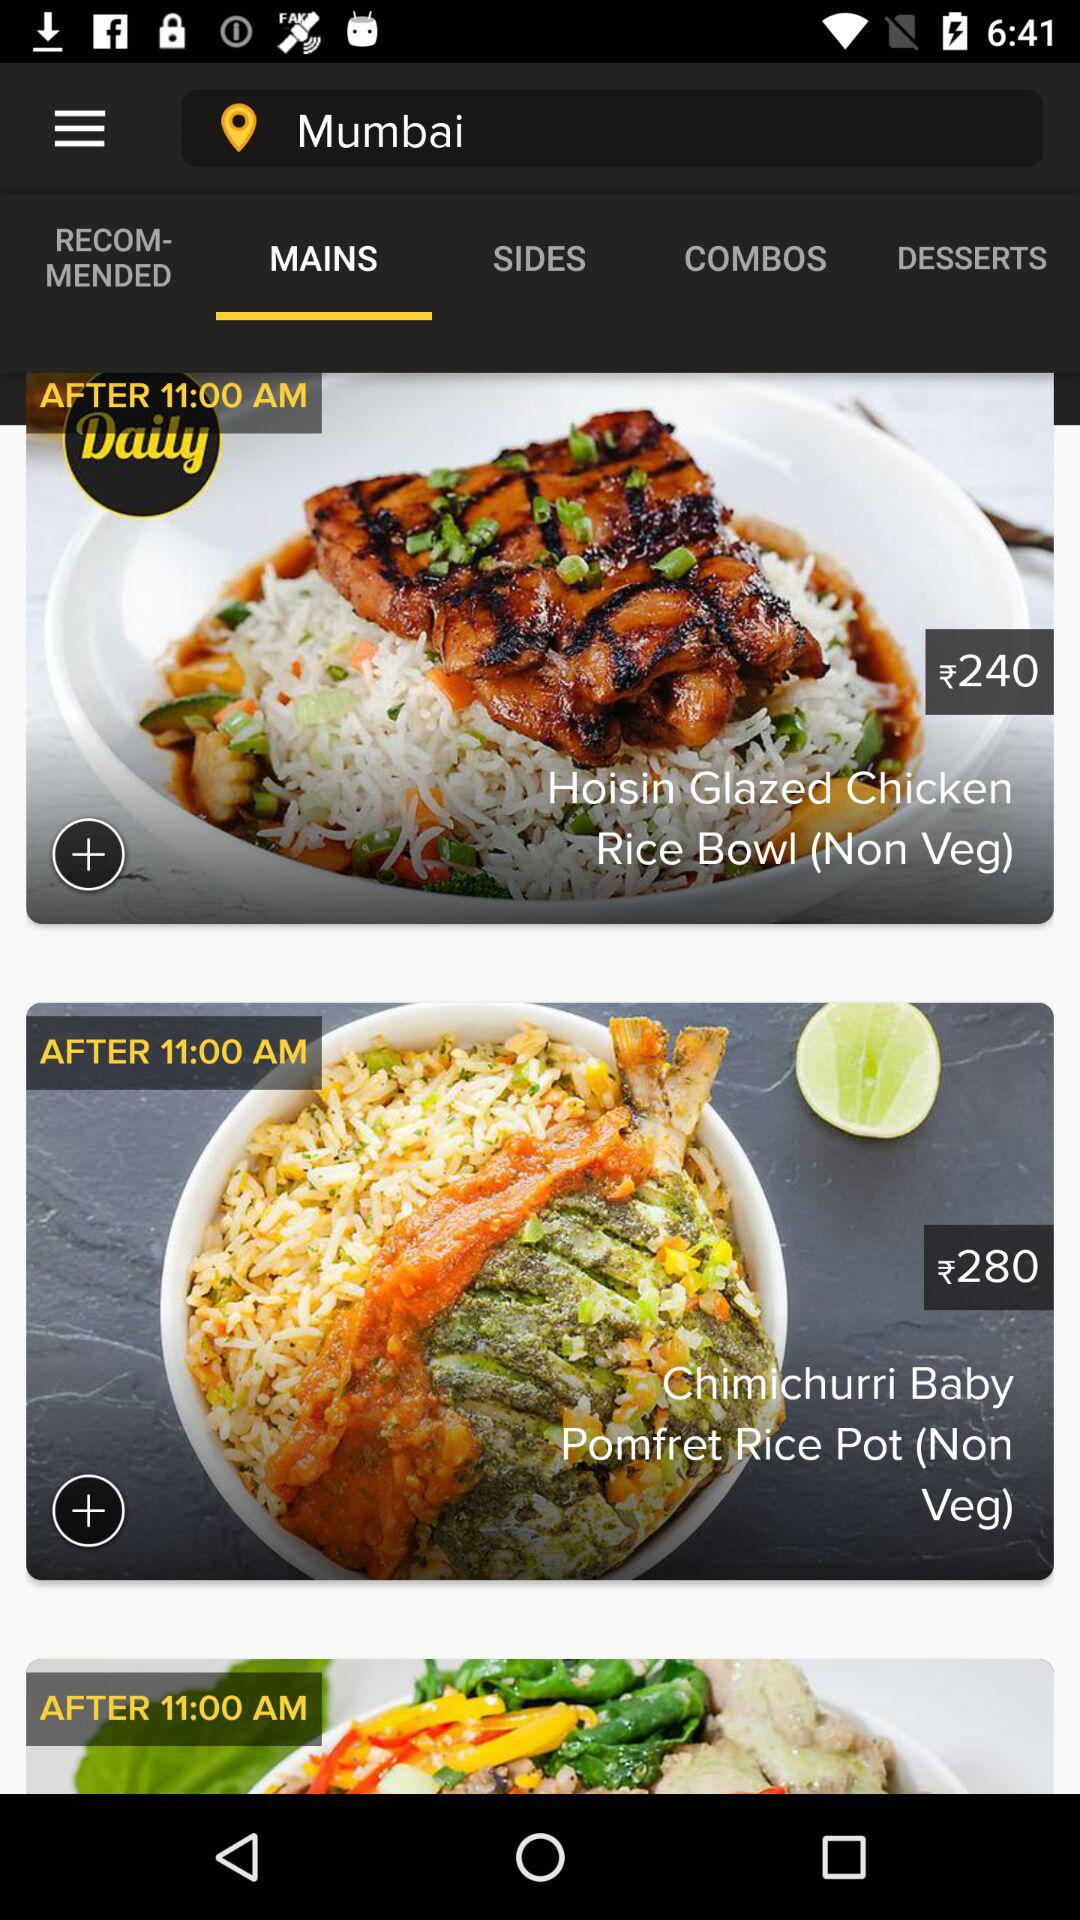How many dish in this?
When the provided information is insufficient, respond with <no answer>. <no answer> 